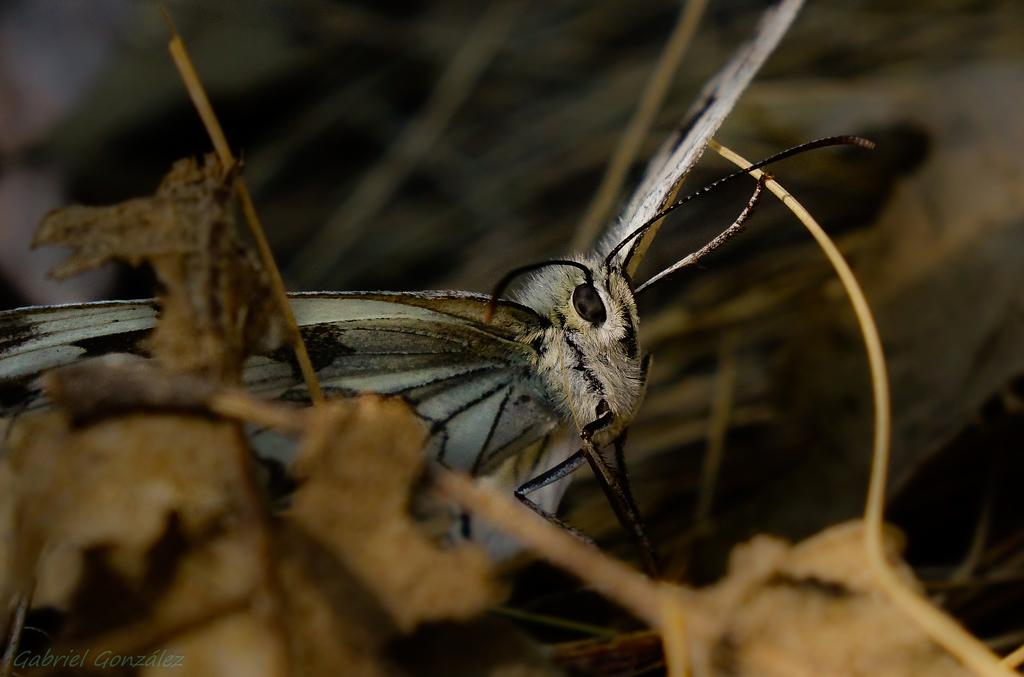What is the main subject of the image? The main subject of the image is a butterfly. Can you describe the color combination of the butterfly? The butterfly has a white and black color combination. Where is the butterfly located in the image? The butterfly is standing on a branch of a tree. What is the condition of the tree in the image? The tree has dry leaves. How would you describe the background of the image? The background of the image is blurred. How many farmers are visible in the image? There are no farmers present in the image; it features a butterfly on a tree branch. What type of boats can be seen in the image? There are no boats present in the image; it features a butterfly on a tree branch. 